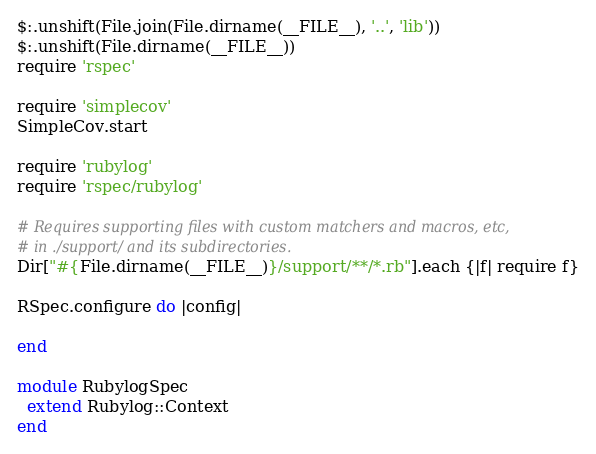Convert code to text. <code><loc_0><loc_0><loc_500><loc_500><_Ruby_>$:.unshift(File.join(File.dirname(__FILE__), '..', 'lib'))
$:.unshift(File.dirname(__FILE__))
require 'rspec'

require 'simplecov'
SimpleCov.start

require 'rubylog'
require 'rspec/rubylog'

# Requires supporting files with custom matchers and macros, etc,
# in ./support/ and its subdirectories.
Dir["#{File.dirname(__FILE__)}/support/**/*.rb"].each {|f| require f}

RSpec.configure do |config|
  
end

module RubylogSpec
  extend Rubylog::Context
end 
</code> 